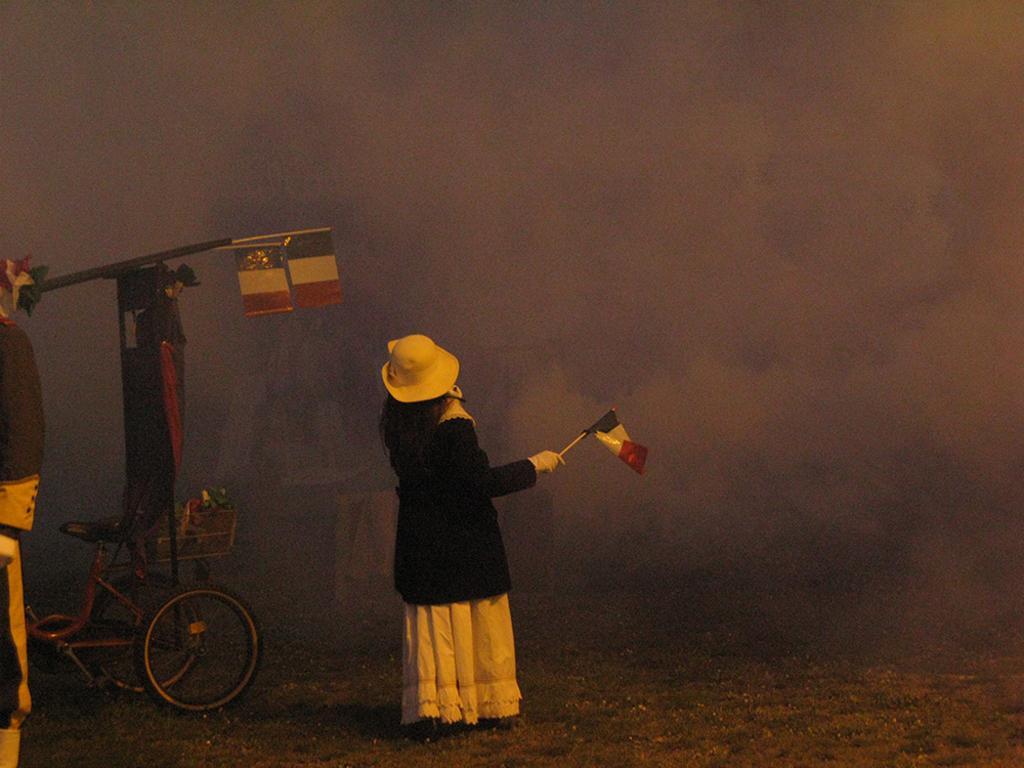Describe this image in one or two sentences. In this image we can see one woman with hat holding a flag and standing on the ground. There is one person truncated on the left side of the image, one object on the ground, two flags, one bicycle on the ground, some grass on the ground, one object on the left side of the image, some objects on the bicycle and the background is blurred. It looks like smoke in the background. 